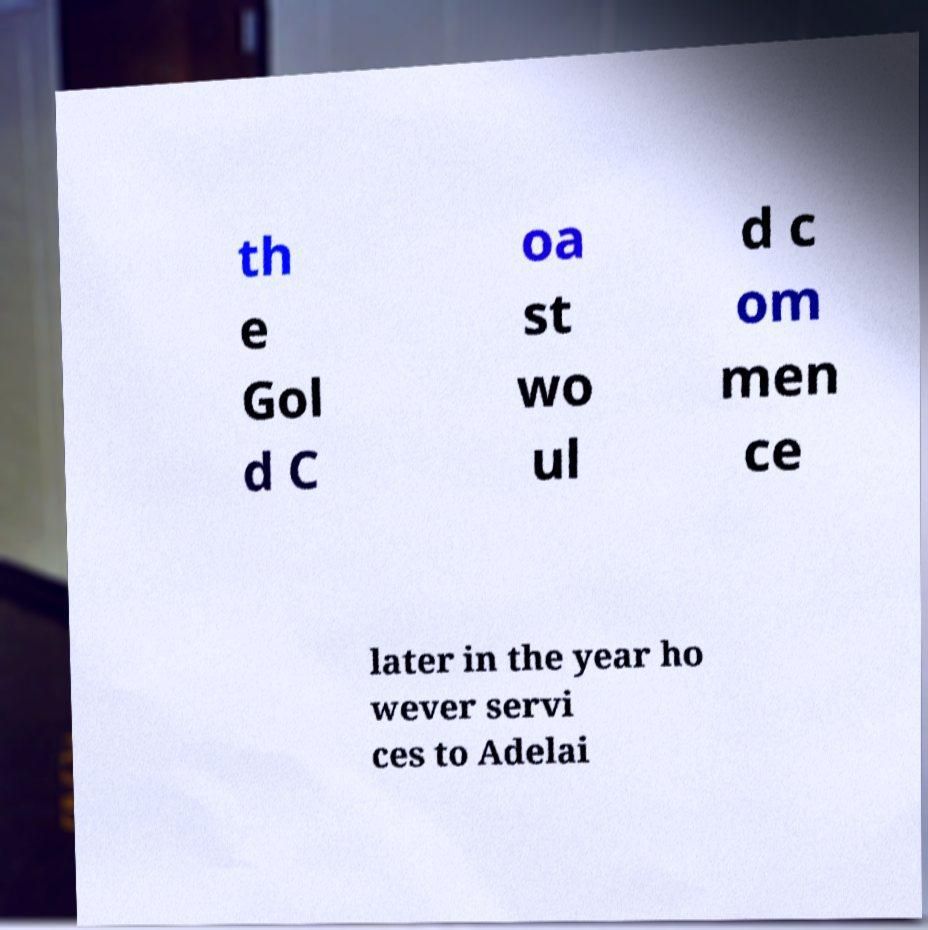For documentation purposes, I need the text within this image transcribed. Could you provide that? th e Gol d C oa st wo ul d c om men ce later in the year ho wever servi ces to Adelai 